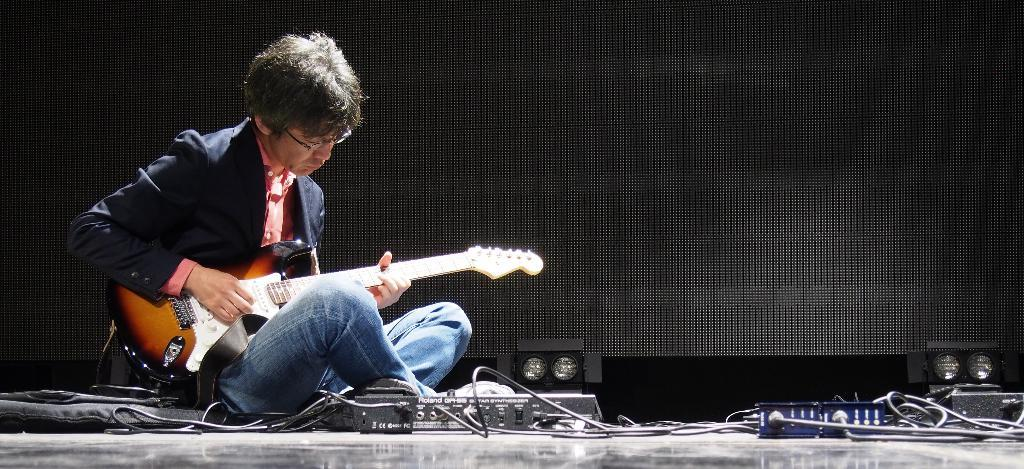What is the person in the image doing? The person is sitting on the floor and playing a guitar. What can be seen connected to the guitar? There are wires visible in the image, which might be connected to the guitar. What else is on the floor in the image? There are objects on the floor, but their specific nature is not mentioned in the facts. What can be seen providing illumination in the image? There are lights in the image. What type of rifle is the person holding in the image? There is no rifle present in the image; the person is playing a guitar. 